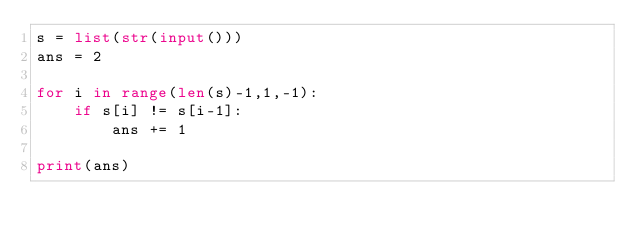<code> <loc_0><loc_0><loc_500><loc_500><_Python_>s = list(str(input()))
ans = 2

for i in range(len(s)-1,1,-1):
    if s[i] != s[i-1]:
        ans += 1

print(ans)</code> 